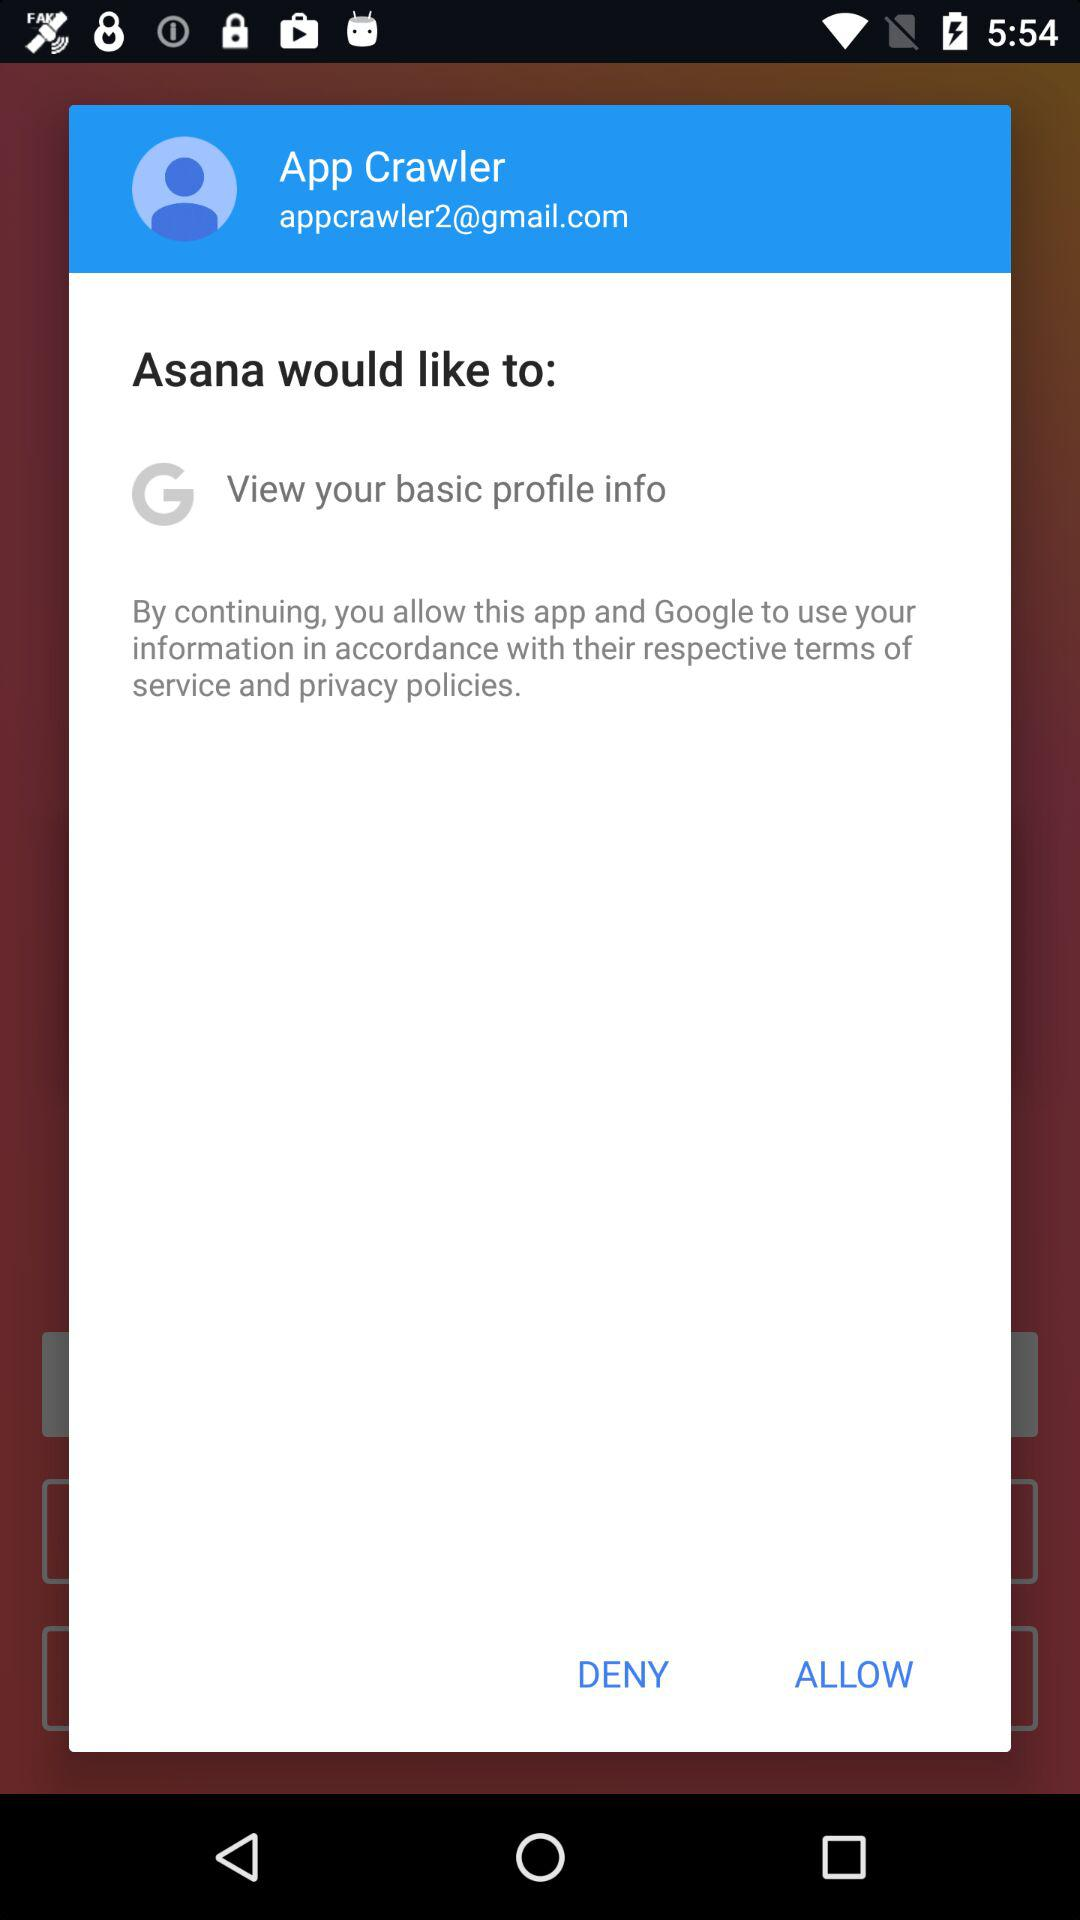What is the email address of the user? The email address is appcrawler2@gmail.com. 